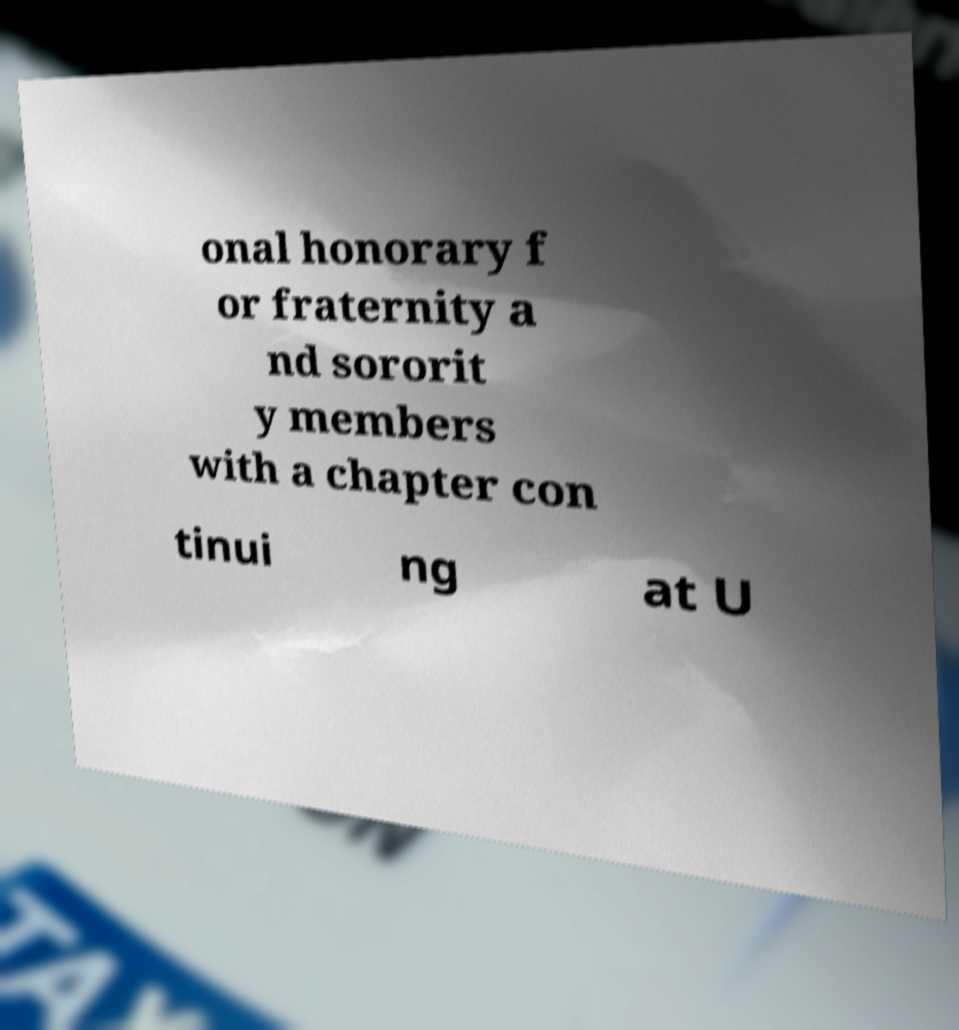There's text embedded in this image that I need extracted. Can you transcribe it verbatim? onal honorary f or fraternity a nd sororit y members with a chapter con tinui ng at U 